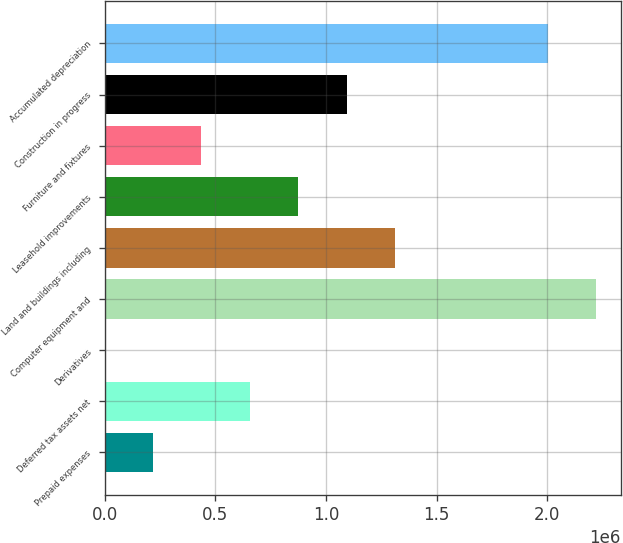Convert chart. <chart><loc_0><loc_0><loc_500><loc_500><bar_chart><fcel>Prepaid expenses<fcel>Deferred tax assets net<fcel>Derivatives<fcel>Computer equipment and<fcel>Land and buildings including<fcel>Leasehold improvements<fcel>Furniture and fixtures<fcel>Construction in progress<fcel>Accumulated depreciation<nl><fcel>218842<fcel>655803<fcel>362<fcel>2.22049e+06<fcel>1.31124e+06<fcel>874283<fcel>437323<fcel>1.09276e+06<fcel>2.002e+06<nl></chart> 